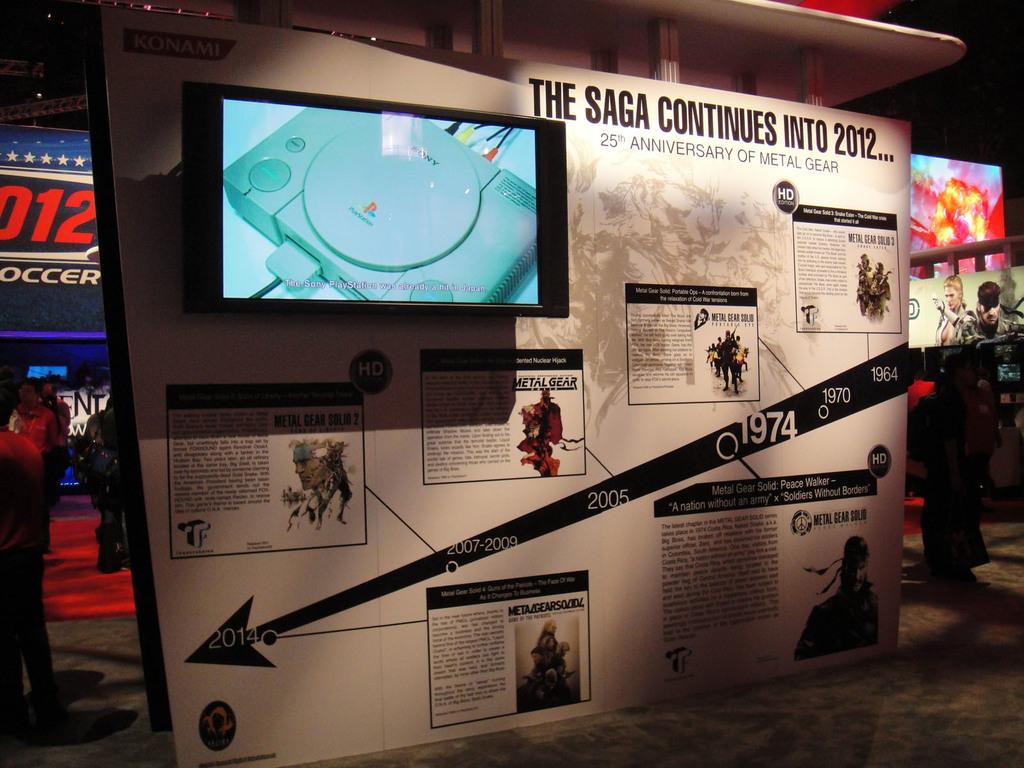Are they celebrating a mainstream gaming anniversary?
Your response must be concise. Yes. What year does the saga continue into?
Provide a short and direct response. 2012. 